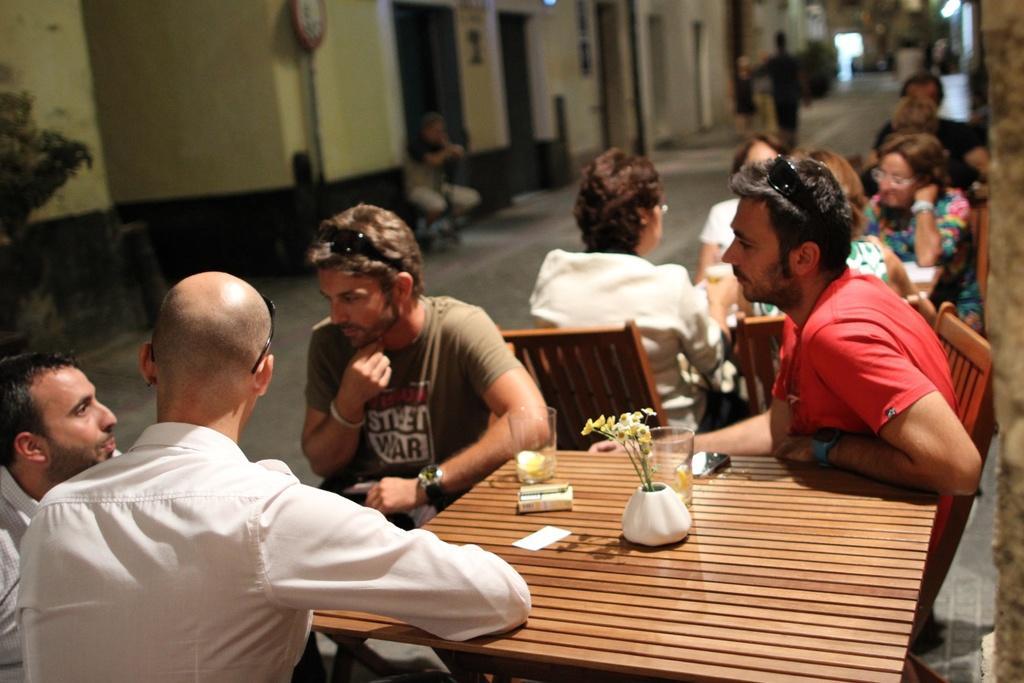Could you give a brief overview of what you see in this image? In this image I see lot of people sitting on the chairs and there is a table over and there are 2 glasses, a flower vase on it. In the background I see the buildings, a person and the path. 